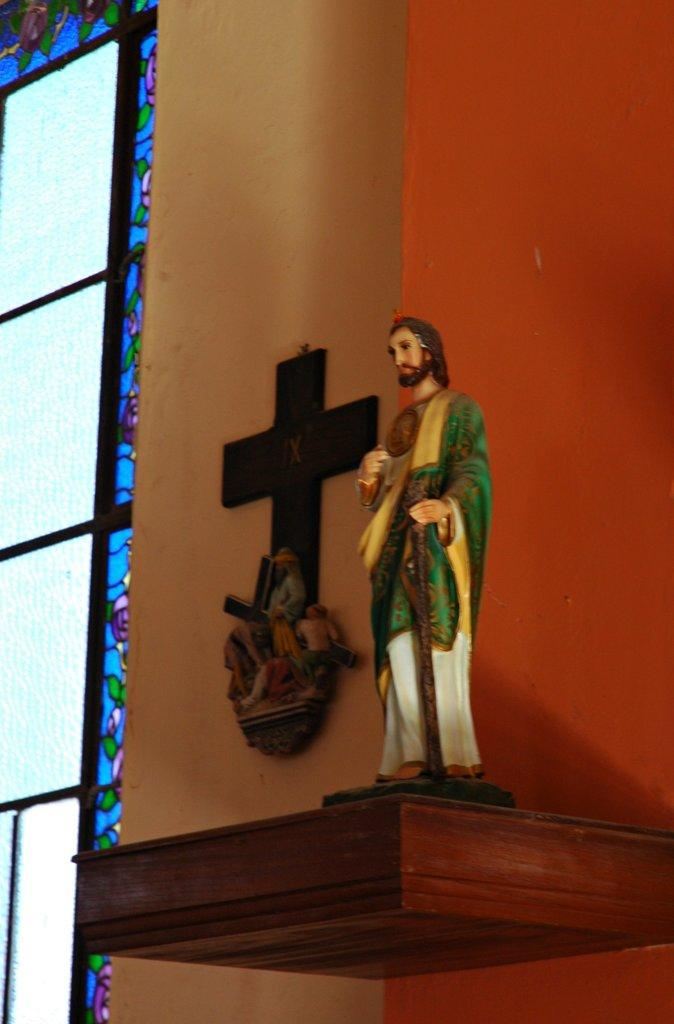What is the main subject of the image? There is a statue of Jesus Christ in the image. What is the statue standing on? The statue is on a wooden plank. What is located behind the statue? There is a cross behind the statue. What type of architectural feature can be seen in the image? There is a glass window on the wall in the image. How does the statue of Jesus Christ help people pay off their debts in the image? The image does not depict the statue of Jesus Christ helping people pay off their debts; it is a statue on a wooden plank with a cross behind it. 